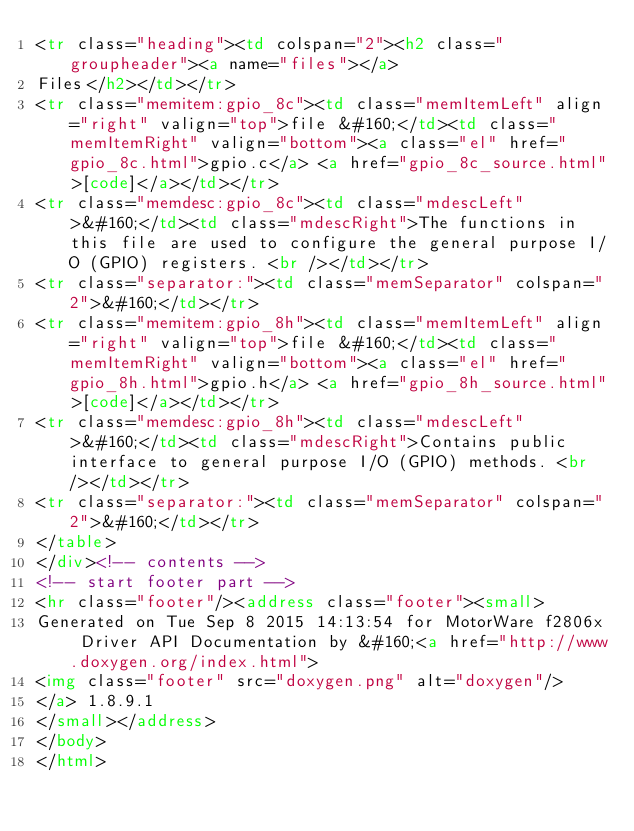Convert code to text. <code><loc_0><loc_0><loc_500><loc_500><_HTML_><tr class="heading"><td colspan="2"><h2 class="groupheader"><a name="files"></a>
Files</h2></td></tr>
<tr class="memitem:gpio_8c"><td class="memItemLeft" align="right" valign="top">file &#160;</td><td class="memItemRight" valign="bottom"><a class="el" href="gpio_8c.html">gpio.c</a> <a href="gpio_8c_source.html">[code]</a></td></tr>
<tr class="memdesc:gpio_8c"><td class="mdescLeft">&#160;</td><td class="mdescRight">The functions in this file are used to configure the general purpose I/O (GPIO) registers. <br /></td></tr>
<tr class="separator:"><td class="memSeparator" colspan="2">&#160;</td></tr>
<tr class="memitem:gpio_8h"><td class="memItemLeft" align="right" valign="top">file &#160;</td><td class="memItemRight" valign="bottom"><a class="el" href="gpio_8h.html">gpio.h</a> <a href="gpio_8h_source.html">[code]</a></td></tr>
<tr class="memdesc:gpio_8h"><td class="mdescLeft">&#160;</td><td class="mdescRight">Contains public interface to general purpose I/O (GPIO) methods. <br /></td></tr>
<tr class="separator:"><td class="memSeparator" colspan="2">&#160;</td></tr>
</table>
</div><!-- contents -->
<!-- start footer part -->
<hr class="footer"/><address class="footer"><small>
Generated on Tue Sep 8 2015 14:13:54 for MotorWare f2806x Driver API Documentation by &#160;<a href="http://www.doxygen.org/index.html">
<img class="footer" src="doxygen.png" alt="doxygen"/>
</a> 1.8.9.1
</small></address>
</body>
</html>
</code> 